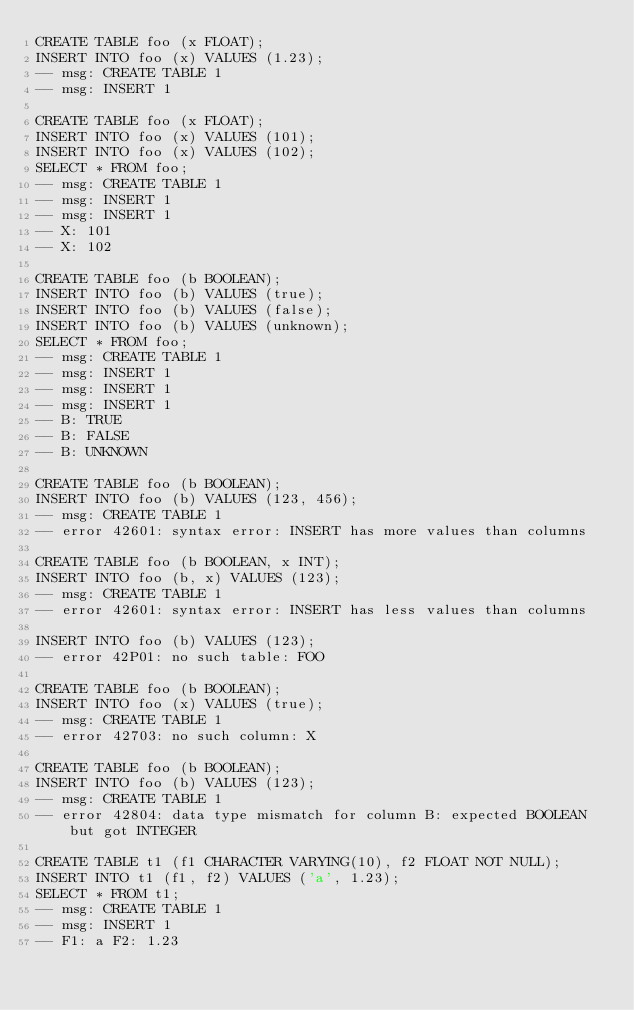Convert code to text. <code><loc_0><loc_0><loc_500><loc_500><_SQL_>CREATE TABLE foo (x FLOAT);
INSERT INTO foo (x) VALUES (1.23);
-- msg: CREATE TABLE 1
-- msg: INSERT 1

CREATE TABLE foo (x FLOAT);
INSERT INTO foo (x) VALUES (101);
INSERT INTO foo (x) VALUES (102);
SELECT * FROM foo;
-- msg: CREATE TABLE 1
-- msg: INSERT 1
-- msg: INSERT 1
-- X: 101
-- X: 102

CREATE TABLE foo (b BOOLEAN);
INSERT INTO foo (b) VALUES (true);
INSERT INTO foo (b) VALUES (false);
INSERT INTO foo (b) VALUES (unknown);
SELECT * FROM foo;
-- msg: CREATE TABLE 1
-- msg: INSERT 1
-- msg: INSERT 1
-- msg: INSERT 1
-- B: TRUE
-- B: FALSE
-- B: UNKNOWN

CREATE TABLE foo (b BOOLEAN);
INSERT INTO foo (b) VALUES (123, 456);
-- msg: CREATE TABLE 1
-- error 42601: syntax error: INSERT has more values than columns

CREATE TABLE foo (b BOOLEAN, x INT);
INSERT INTO foo (b, x) VALUES (123);
-- msg: CREATE TABLE 1
-- error 42601: syntax error: INSERT has less values than columns

INSERT INTO foo (b) VALUES (123);
-- error 42P01: no such table: FOO

CREATE TABLE foo (b BOOLEAN);
INSERT INTO foo (x) VALUES (true);
-- msg: CREATE TABLE 1
-- error 42703: no such column: X

CREATE TABLE foo (b BOOLEAN);
INSERT INTO foo (b) VALUES (123);
-- msg: CREATE TABLE 1
-- error 42804: data type mismatch for column B: expected BOOLEAN but got INTEGER

CREATE TABLE t1 (f1 CHARACTER VARYING(10), f2 FLOAT NOT NULL);
INSERT INTO t1 (f1, f2) VALUES ('a', 1.23);
SELECT * FROM t1;
-- msg: CREATE TABLE 1
-- msg: INSERT 1
-- F1: a F2: 1.23
</code> 